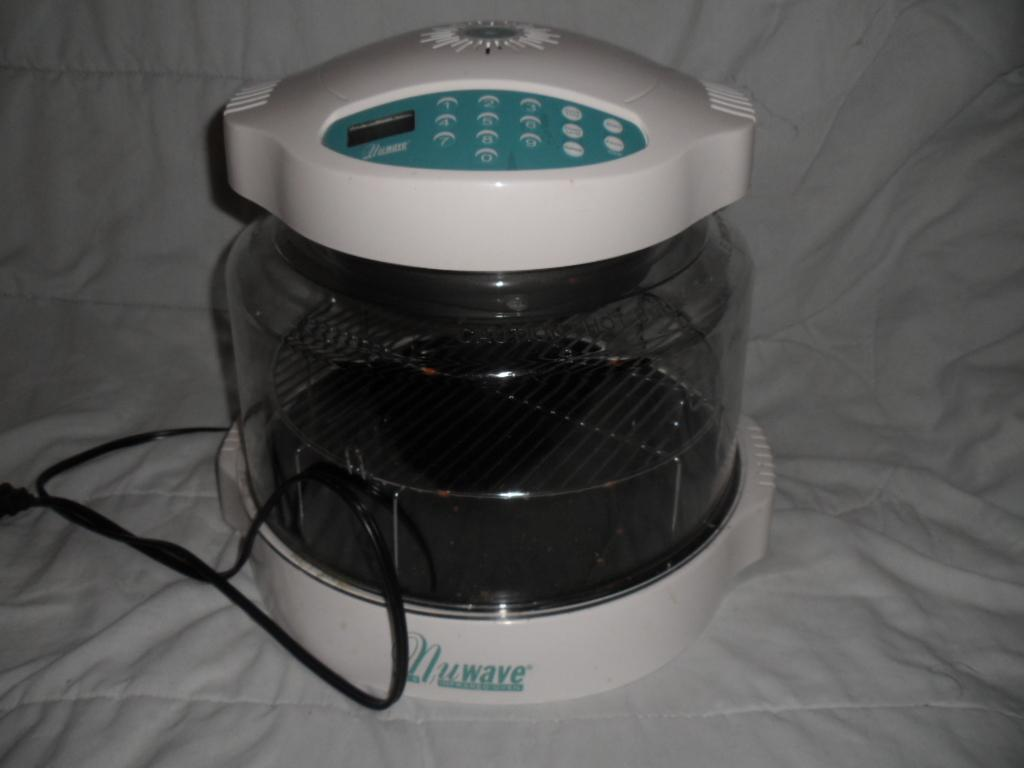<image>
Present a compact description of the photo's key features. A Nuwave electronic device on a white blanket. 